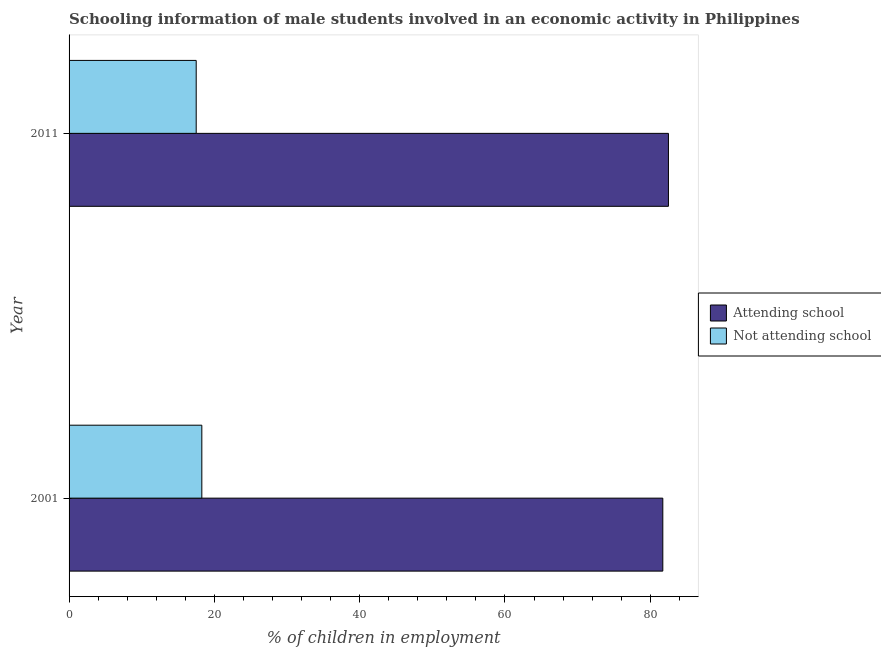Are the number of bars on each tick of the Y-axis equal?
Provide a succinct answer. Yes. How many bars are there on the 1st tick from the bottom?
Keep it short and to the point. 2. What is the label of the 1st group of bars from the top?
Your response must be concise. 2011. In how many cases, is the number of bars for a given year not equal to the number of legend labels?
Keep it short and to the point. 0. What is the percentage of employed males who are not attending school in 2001?
Keep it short and to the point. 18.27. Across all years, what is the maximum percentage of employed males who are not attending school?
Ensure brevity in your answer.  18.27. Across all years, what is the minimum percentage of employed males who are attending school?
Your answer should be very brief. 81.73. In which year was the percentage of employed males who are not attending school minimum?
Ensure brevity in your answer.  2011. What is the total percentage of employed males who are attending school in the graph?
Your answer should be compact. 164.23. What is the difference between the percentage of employed males who are attending school in 2001 and that in 2011?
Offer a very short reply. -0.77. What is the difference between the percentage of employed males who are attending school in 2011 and the percentage of employed males who are not attending school in 2001?
Ensure brevity in your answer.  64.23. What is the average percentage of employed males who are not attending school per year?
Provide a short and direct response. 17.89. In how many years, is the percentage of employed males who are attending school greater than 44 %?
Offer a very short reply. 2. What is the ratio of the percentage of employed males who are not attending school in 2001 to that in 2011?
Your answer should be compact. 1.04. Is the percentage of employed males who are not attending school in 2001 less than that in 2011?
Ensure brevity in your answer.  No. Is the difference between the percentage of employed males who are not attending school in 2001 and 2011 greater than the difference between the percentage of employed males who are attending school in 2001 and 2011?
Ensure brevity in your answer.  Yes. In how many years, is the percentage of employed males who are not attending school greater than the average percentage of employed males who are not attending school taken over all years?
Make the answer very short. 1. What does the 1st bar from the top in 2011 represents?
Give a very brief answer. Not attending school. What does the 2nd bar from the bottom in 2011 represents?
Your answer should be compact. Not attending school. How many bars are there?
Your response must be concise. 4. What is the difference between two consecutive major ticks on the X-axis?
Offer a terse response. 20. Are the values on the major ticks of X-axis written in scientific E-notation?
Ensure brevity in your answer.  No. Does the graph contain any zero values?
Offer a very short reply. No. How many legend labels are there?
Ensure brevity in your answer.  2. What is the title of the graph?
Make the answer very short. Schooling information of male students involved in an economic activity in Philippines. What is the label or title of the X-axis?
Provide a succinct answer. % of children in employment. What is the % of children in employment of Attending school in 2001?
Ensure brevity in your answer.  81.73. What is the % of children in employment in Not attending school in 2001?
Make the answer very short. 18.27. What is the % of children in employment of Attending school in 2011?
Your answer should be very brief. 82.5. What is the % of children in employment in Not attending school in 2011?
Your answer should be very brief. 17.5. Across all years, what is the maximum % of children in employment of Attending school?
Ensure brevity in your answer.  82.5. Across all years, what is the maximum % of children in employment of Not attending school?
Your response must be concise. 18.27. Across all years, what is the minimum % of children in employment in Attending school?
Your answer should be compact. 81.73. What is the total % of children in employment in Attending school in the graph?
Offer a terse response. 164.23. What is the total % of children in employment in Not attending school in the graph?
Offer a terse response. 35.77. What is the difference between the % of children in employment in Attending school in 2001 and that in 2011?
Make the answer very short. -0.77. What is the difference between the % of children in employment of Not attending school in 2001 and that in 2011?
Offer a terse response. 0.77. What is the difference between the % of children in employment in Attending school in 2001 and the % of children in employment in Not attending school in 2011?
Your response must be concise. 64.23. What is the average % of children in employment in Attending school per year?
Provide a succinct answer. 82.11. What is the average % of children in employment in Not attending school per year?
Provide a short and direct response. 17.89. In the year 2001, what is the difference between the % of children in employment of Attending school and % of children in employment of Not attending school?
Make the answer very short. 63.45. What is the ratio of the % of children in employment in Attending school in 2001 to that in 2011?
Keep it short and to the point. 0.99. What is the ratio of the % of children in employment of Not attending school in 2001 to that in 2011?
Give a very brief answer. 1.04. What is the difference between the highest and the second highest % of children in employment of Attending school?
Make the answer very short. 0.77. What is the difference between the highest and the second highest % of children in employment in Not attending school?
Keep it short and to the point. 0.77. What is the difference between the highest and the lowest % of children in employment of Attending school?
Ensure brevity in your answer.  0.77. What is the difference between the highest and the lowest % of children in employment of Not attending school?
Ensure brevity in your answer.  0.77. 